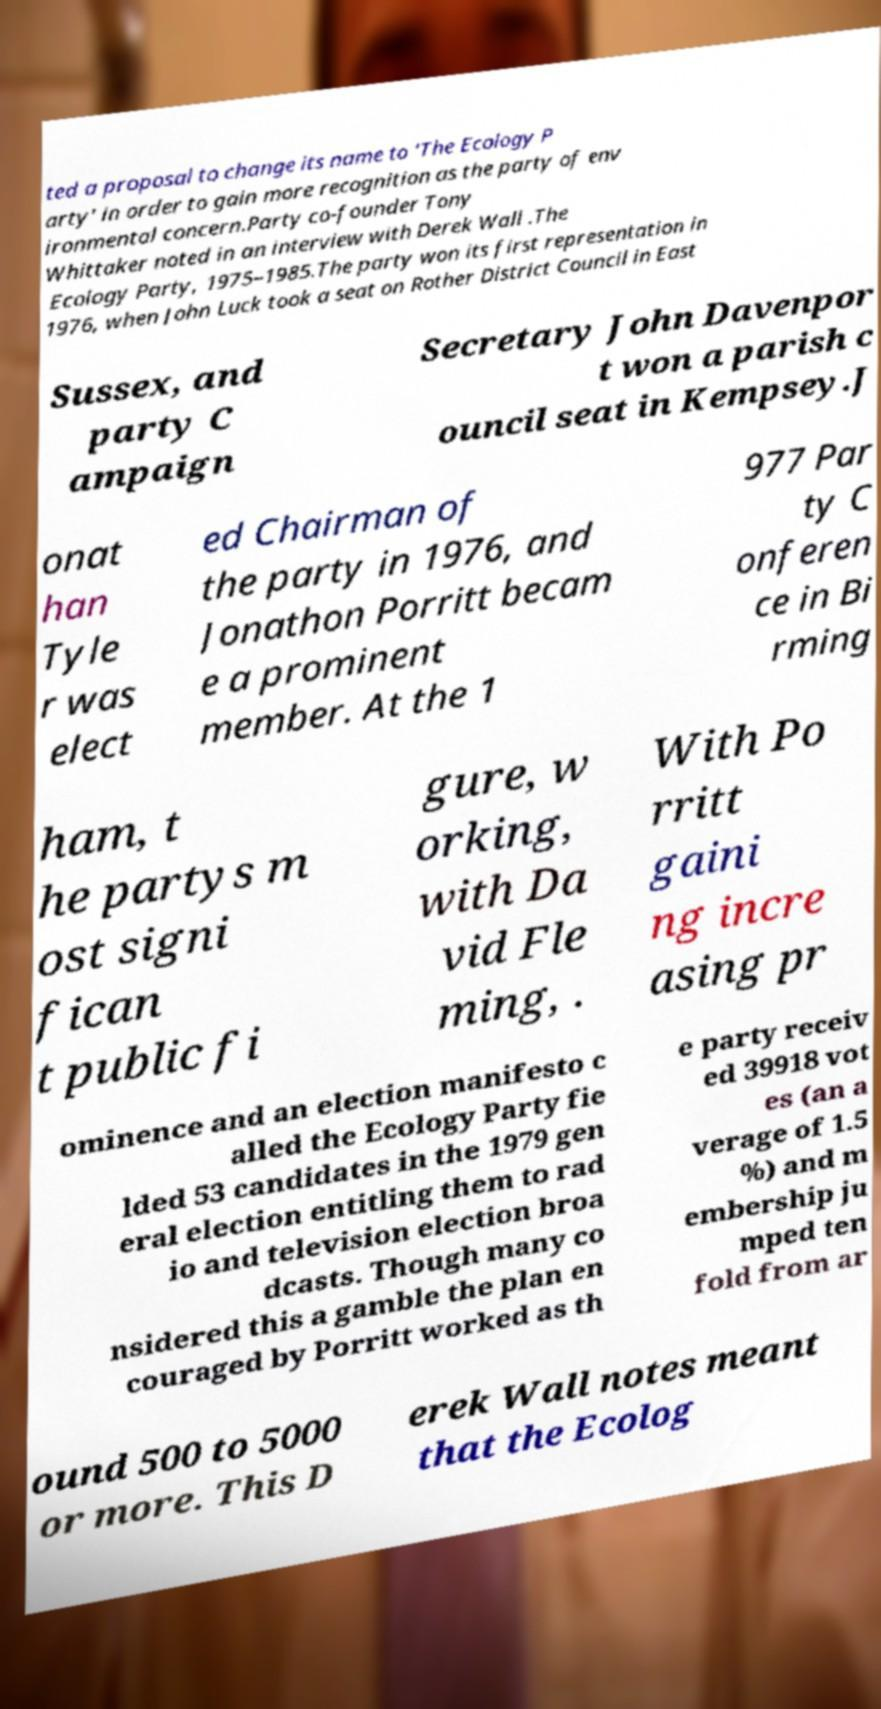For documentation purposes, I need the text within this image transcribed. Could you provide that? ted a proposal to change its name to 'The Ecology P arty' in order to gain more recognition as the party of env ironmental concern.Party co-founder Tony Whittaker noted in an interview with Derek Wall .The Ecology Party, 1975–1985.The party won its first representation in 1976, when John Luck took a seat on Rother District Council in East Sussex, and party C ampaign Secretary John Davenpor t won a parish c ouncil seat in Kempsey.J onat han Tyle r was elect ed Chairman of the party in 1976, and Jonathon Porritt becam e a prominent member. At the 1 977 Par ty C onferen ce in Bi rming ham, t he partys m ost signi fican t public fi gure, w orking, with Da vid Fle ming, . With Po rritt gaini ng incre asing pr ominence and an election manifesto c alled the Ecology Party fie lded 53 candidates in the 1979 gen eral election entitling them to rad io and television election broa dcasts. Though many co nsidered this a gamble the plan en couraged by Porritt worked as th e party receiv ed 39918 vot es (an a verage of 1.5 %) and m embership ju mped ten fold from ar ound 500 to 5000 or more. This D erek Wall notes meant that the Ecolog 